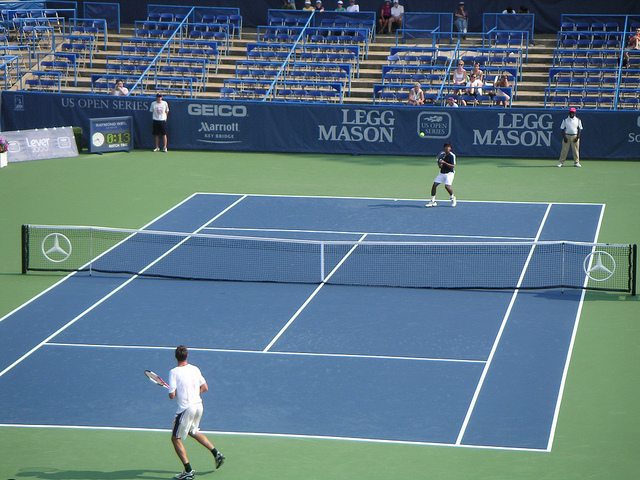Identify the text contained in this image. GEICO Marrtoll LEGG MASON LEGG MASON US OPEN SERIES 0:13 